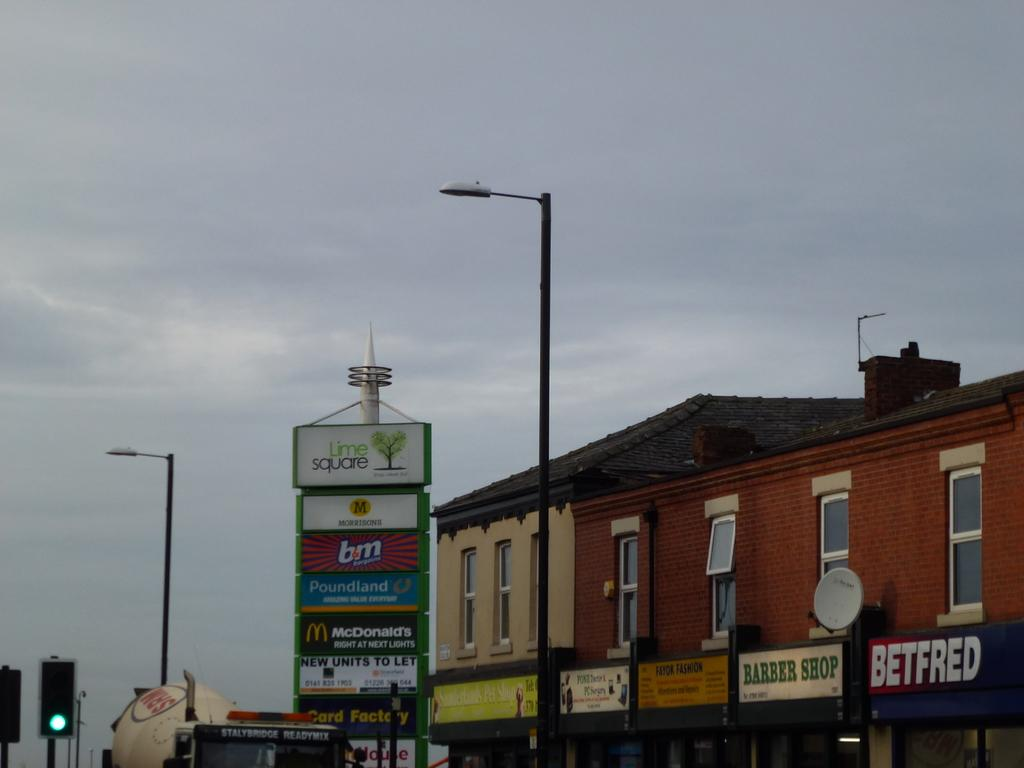Provide a one-sentence caption for the provided image. Store fronts from the shopping plaza Lime Square. 